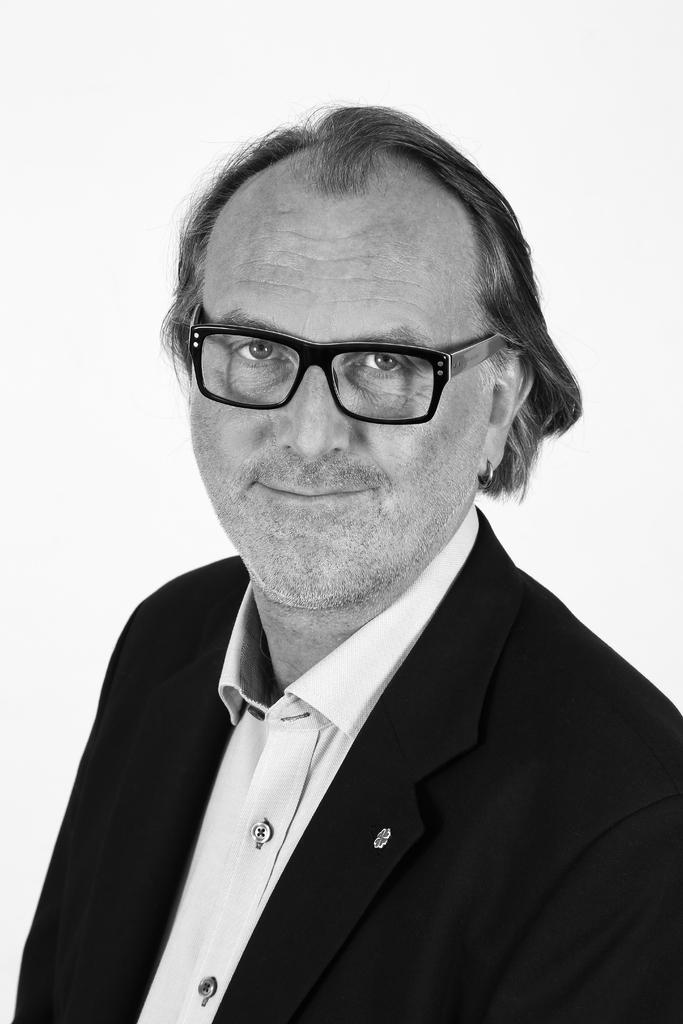What is the color scheme of the image? The image is black and white. Who is present in the image? There is a man in the image. What is the man doing in the image? The man is posing for a photo. What accessory is the man wearing in the image? The man is wearing spectacles. What type of bat can be seen flying in the image? There is no bat present in the image; it is a black and white photo of a man posing for a photo while wearing spectacles. 